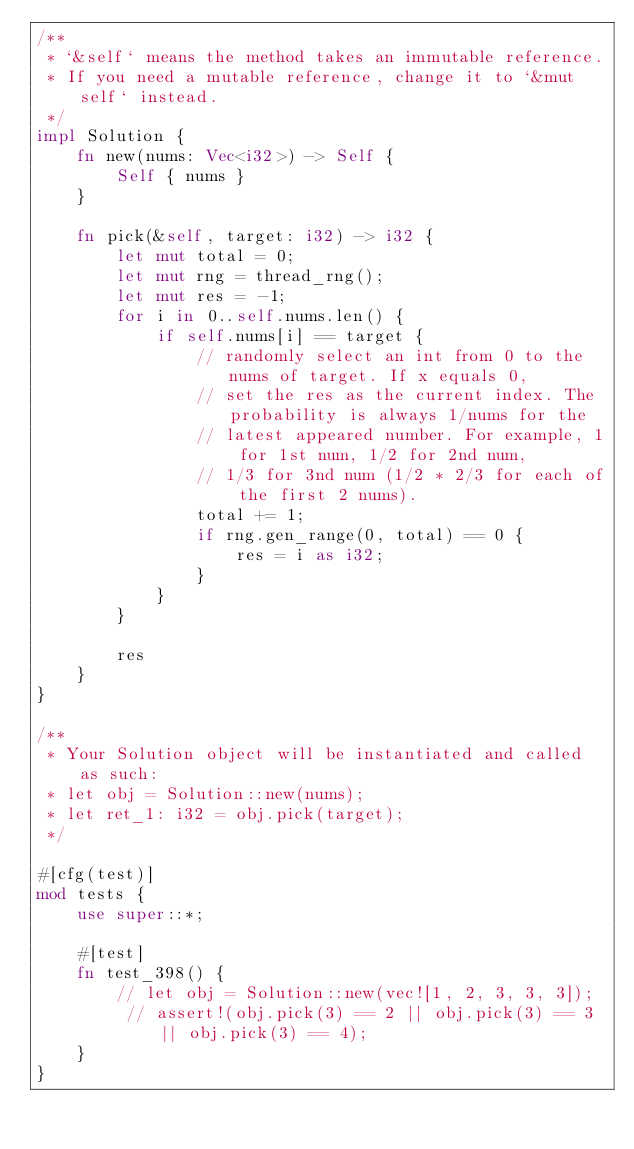<code> <loc_0><loc_0><loc_500><loc_500><_Rust_>/**
 * `&self` means the method takes an immutable reference.
 * If you need a mutable reference, change it to `&mut self` instead.
 */
impl Solution {
    fn new(nums: Vec<i32>) -> Self {
        Self { nums }
    }

    fn pick(&self, target: i32) -> i32 {
        let mut total = 0;
        let mut rng = thread_rng();
        let mut res = -1;
        for i in 0..self.nums.len() {
            if self.nums[i] == target {
                // randomly select an int from 0 to the nums of target. If x equals 0,
                // set the res as the current index. The probability is always 1/nums for the
                // latest appeared number. For example, 1 for 1st num, 1/2 for 2nd num,
                // 1/3 for 3nd num (1/2 * 2/3 for each of the first 2 nums).
                total += 1;
                if rng.gen_range(0, total) == 0 {
                    res = i as i32;
                }
            }
        }

        res
    }
}

/**
 * Your Solution object will be instantiated and called as such:
 * let obj = Solution::new(nums);
 * let ret_1: i32 = obj.pick(target);
 */

#[cfg(test)]
mod tests {
    use super::*;

    #[test]
    fn test_398() {
        // let obj = Solution::new(vec![1, 2, 3, 3, 3]);
         // assert!(obj.pick(3) == 2 || obj.pick(3) == 3 || obj.pick(3) == 4);
    }
}
</code> 